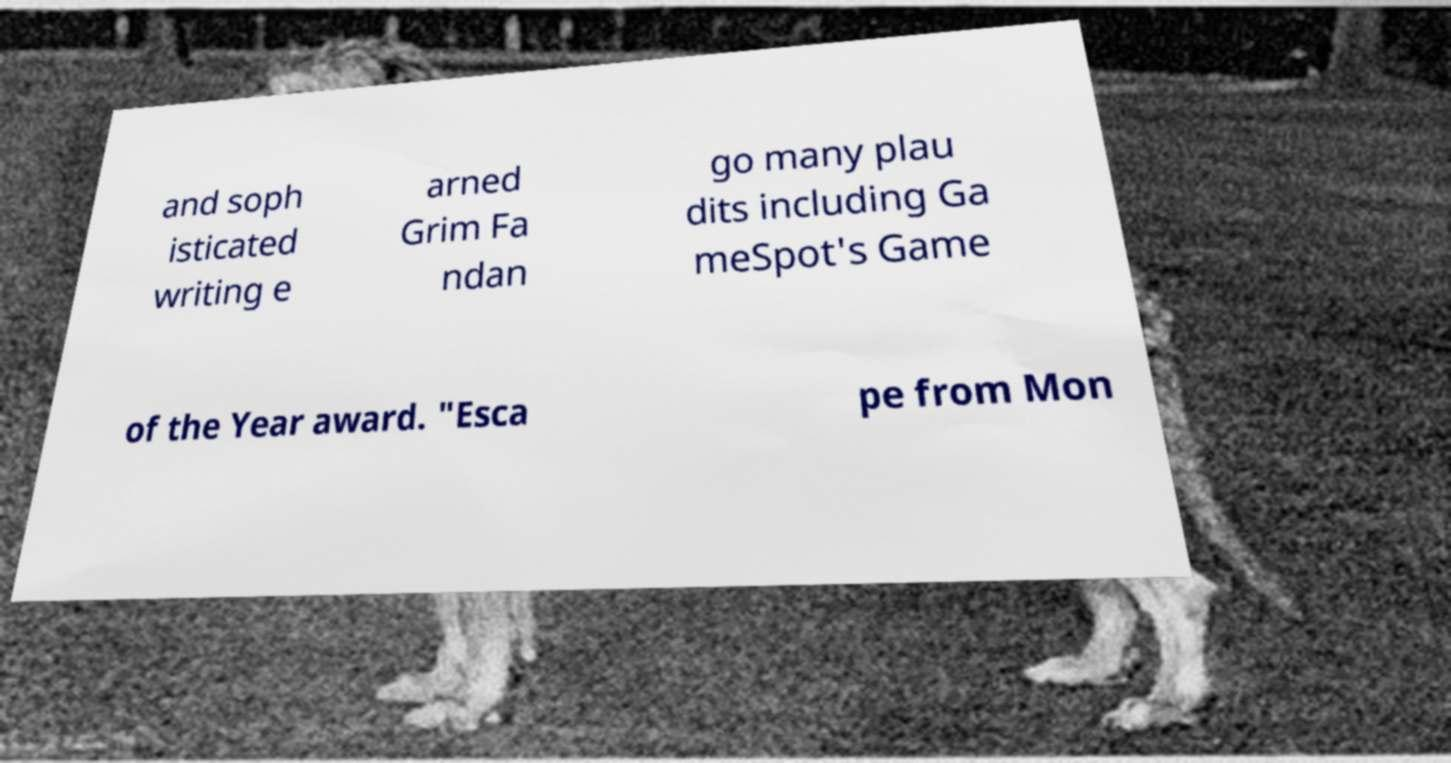Can you accurately transcribe the text from the provided image for me? and soph isticated writing e arned Grim Fa ndan go many plau dits including Ga meSpot's Game of the Year award. "Esca pe from Mon 